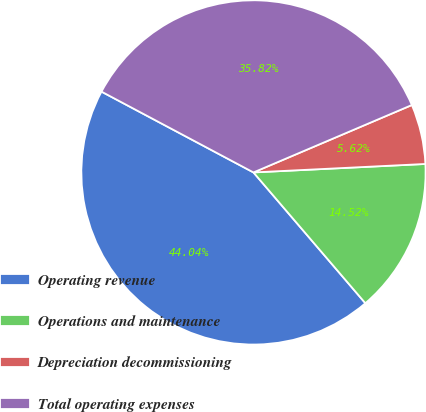Convert chart. <chart><loc_0><loc_0><loc_500><loc_500><pie_chart><fcel>Operating revenue<fcel>Operations and maintenance<fcel>Depreciation decommissioning<fcel>Total operating expenses<nl><fcel>44.04%<fcel>14.52%<fcel>5.62%<fcel>35.82%<nl></chart> 